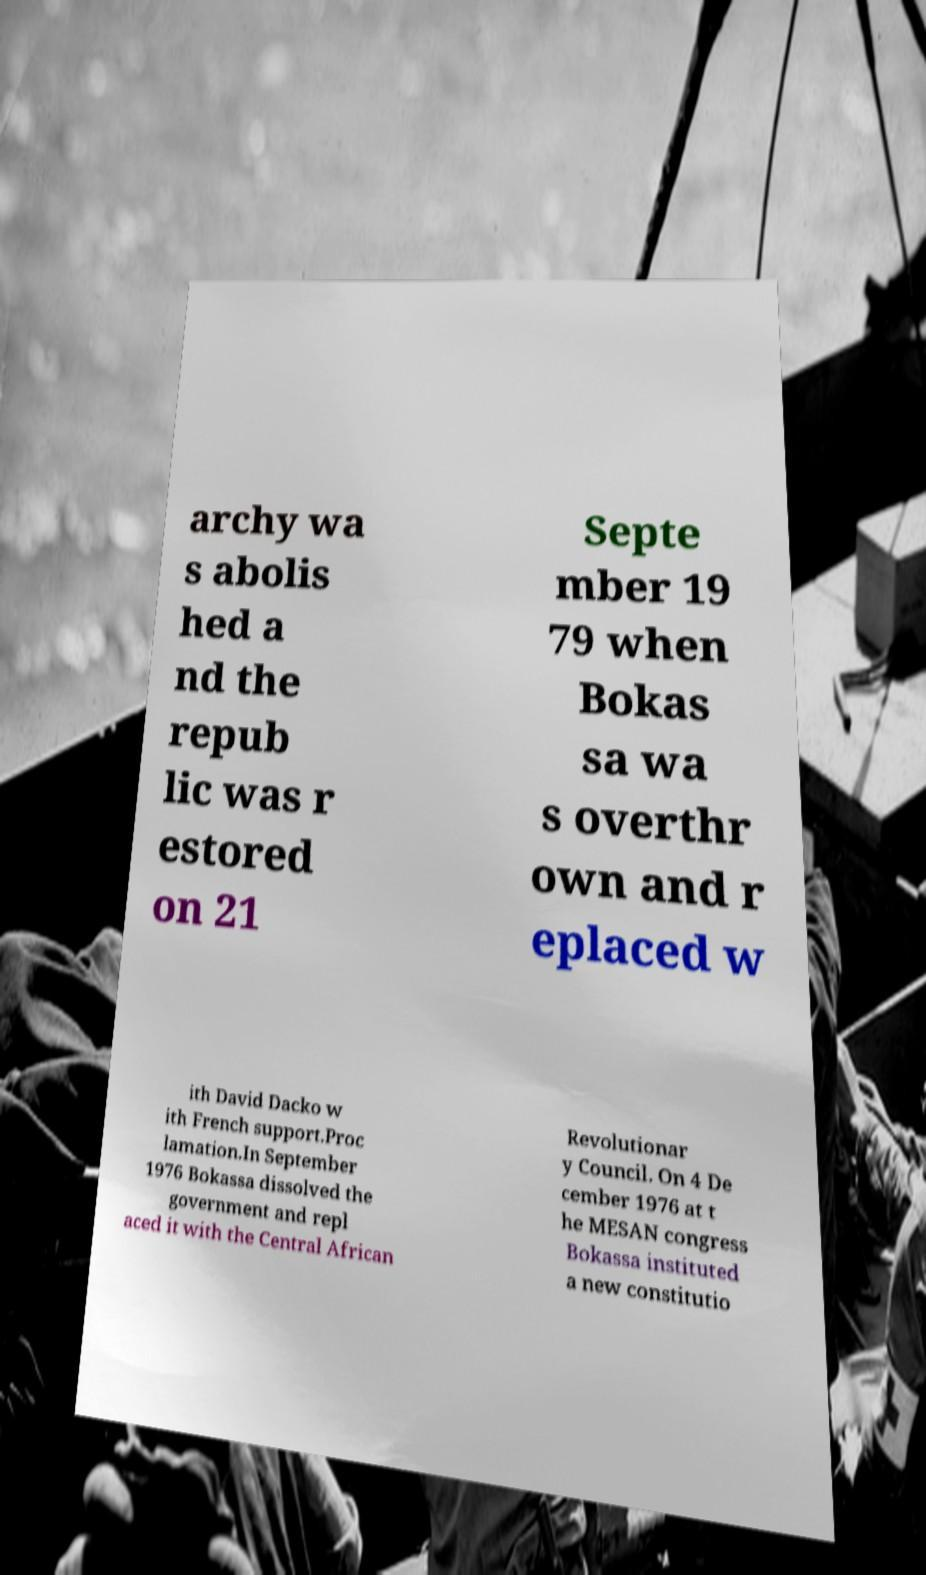Please read and relay the text visible in this image. What does it say? archy wa s abolis hed a nd the repub lic was r estored on 21 Septe mber 19 79 when Bokas sa wa s overthr own and r eplaced w ith David Dacko w ith French support.Proc lamation.In September 1976 Bokassa dissolved the government and repl aced it with the Central African Revolutionar y Council. On 4 De cember 1976 at t he MESAN congress Bokassa instituted a new constitutio 